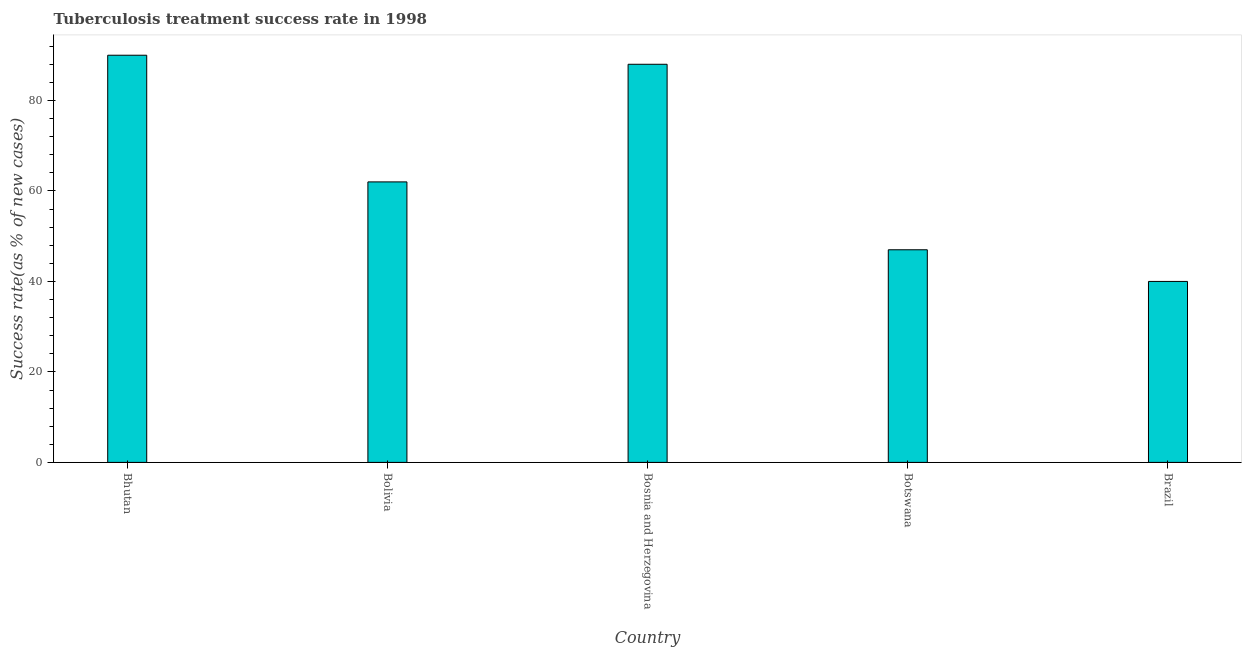Does the graph contain grids?
Keep it short and to the point. No. What is the title of the graph?
Offer a very short reply. Tuberculosis treatment success rate in 1998. What is the label or title of the X-axis?
Provide a succinct answer. Country. What is the label or title of the Y-axis?
Give a very brief answer. Success rate(as % of new cases). In which country was the tuberculosis treatment success rate maximum?
Your answer should be compact. Bhutan. In which country was the tuberculosis treatment success rate minimum?
Give a very brief answer. Brazil. What is the sum of the tuberculosis treatment success rate?
Make the answer very short. 327. What is the difference between the tuberculosis treatment success rate in Bolivia and Bosnia and Herzegovina?
Give a very brief answer. -26. What is the median tuberculosis treatment success rate?
Your answer should be compact. 62. What is the ratio of the tuberculosis treatment success rate in Botswana to that in Brazil?
Offer a very short reply. 1.18. Is the difference between the tuberculosis treatment success rate in Bosnia and Herzegovina and Brazil greater than the difference between any two countries?
Ensure brevity in your answer.  No. In how many countries, is the tuberculosis treatment success rate greater than the average tuberculosis treatment success rate taken over all countries?
Your response must be concise. 2. How many bars are there?
Provide a short and direct response. 5. What is the difference between two consecutive major ticks on the Y-axis?
Your answer should be compact. 20. Are the values on the major ticks of Y-axis written in scientific E-notation?
Provide a succinct answer. No. What is the Success rate(as % of new cases) of Bhutan?
Give a very brief answer. 90. What is the Success rate(as % of new cases) in Bolivia?
Make the answer very short. 62. What is the Success rate(as % of new cases) in Bosnia and Herzegovina?
Offer a terse response. 88. What is the Success rate(as % of new cases) of Botswana?
Your answer should be compact. 47. What is the Success rate(as % of new cases) in Brazil?
Offer a terse response. 40. What is the difference between the Success rate(as % of new cases) in Bhutan and Bolivia?
Ensure brevity in your answer.  28. What is the difference between the Success rate(as % of new cases) in Bolivia and Bosnia and Herzegovina?
Your answer should be compact. -26. What is the difference between the Success rate(as % of new cases) in Bosnia and Herzegovina and Botswana?
Keep it short and to the point. 41. What is the difference between the Success rate(as % of new cases) in Bosnia and Herzegovina and Brazil?
Offer a very short reply. 48. What is the difference between the Success rate(as % of new cases) in Botswana and Brazil?
Make the answer very short. 7. What is the ratio of the Success rate(as % of new cases) in Bhutan to that in Bolivia?
Provide a succinct answer. 1.45. What is the ratio of the Success rate(as % of new cases) in Bhutan to that in Botswana?
Provide a succinct answer. 1.92. What is the ratio of the Success rate(as % of new cases) in Bhutan to that in Brazil?
Your response must be concise. 2.25. What is the ratio of the Success rate(as % of new cases) in Bolivia to that in Bosnia and Herzegovina?
Offer a terse response. 0.7. What is the ratio of the Success rate(as % of new cases) in Bolivia to that in Botswana?
Ensure brevity in your answer.  1.32. What is the ratio of the Success rate(as % of new cases) in Bolivia to that in Brazil?
Provide a succinct answer. 1.55. What is the ratio of the Success rate(as % of new cases) in Bosnia and Herzegovina to that in Botswana?
Keep it short and to the point. 1.87. What is the ratio of the Success rate(as % of new cases) in Botswana to that in Brazil?
Provide a succinct answer. 1.18. 